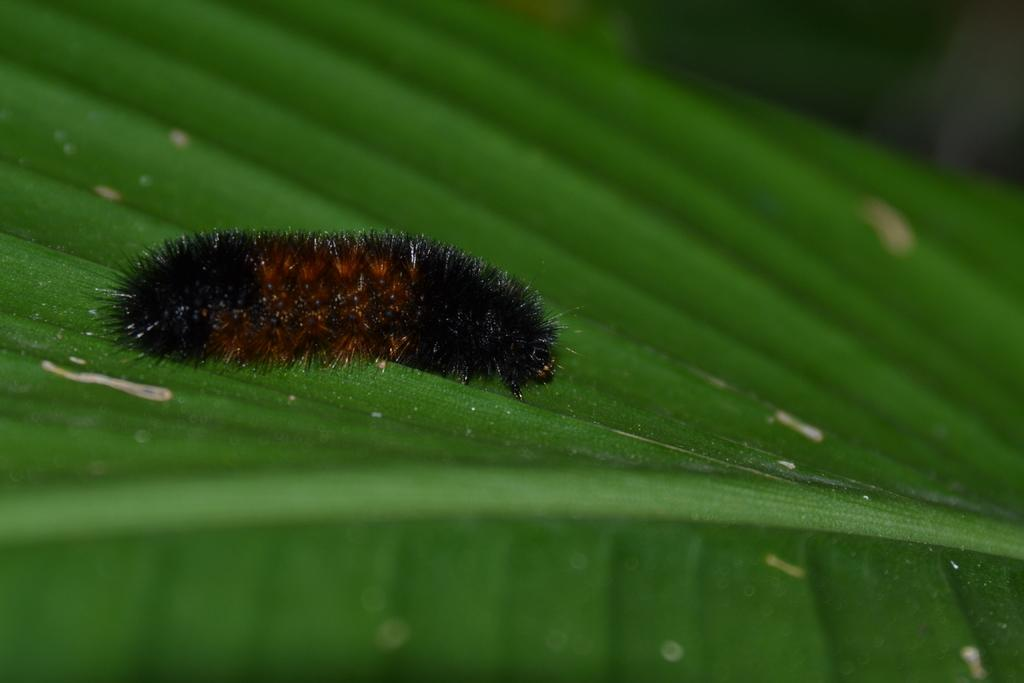What type of insect is in the image? There is a black color caterpillar in the image. What is the caterpillar resting on in the image? The caterpillar is on a green color leaf. How many pies are being served at the camp in the image? There is no mention of pies or a camp in the image; it features a black color caterpillar on a green color leaf. 